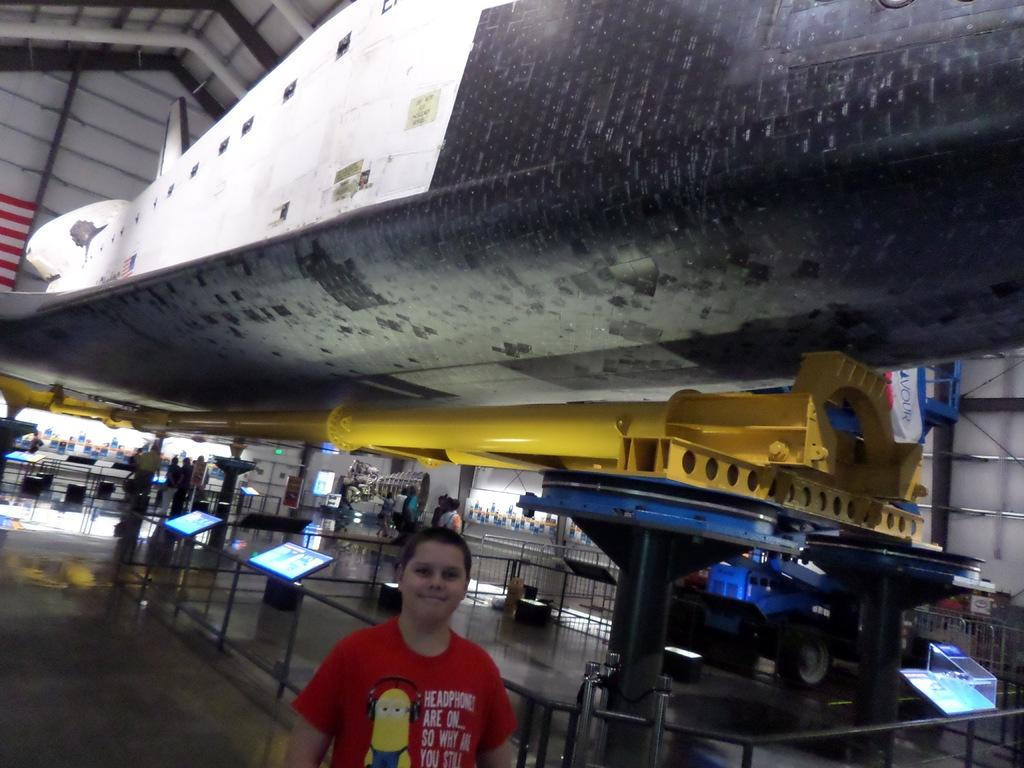What is the person in the image wearing? The person is wearing a red shirt. What can be seen in the background of the image? There are screens visible in the background. How many people are standing in the image? There are other people standing in the image, in addition to the person wearing the red shirt. What is the color of the pole in the image? There is a yellow pole in the image. What type of kite is being flown by the person in the image? There is no kite present in the image; the person is wearing a red shirt and standing near a yellow pole. 